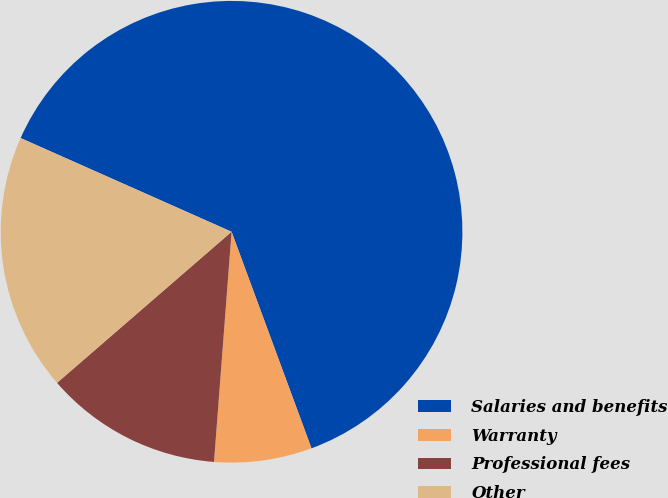Convert chart to OTSL. <chart><loc_0><loc_0><loc_500><loc_500><pie_chart><fcel>Salaries and benefits<fcel>Warranty<fcel>Professional fees<fcel>Other<nl><fcel>62.72%<fcel>6.84%<fcel>12.43%<fcel>18.01%<nl></chart> 